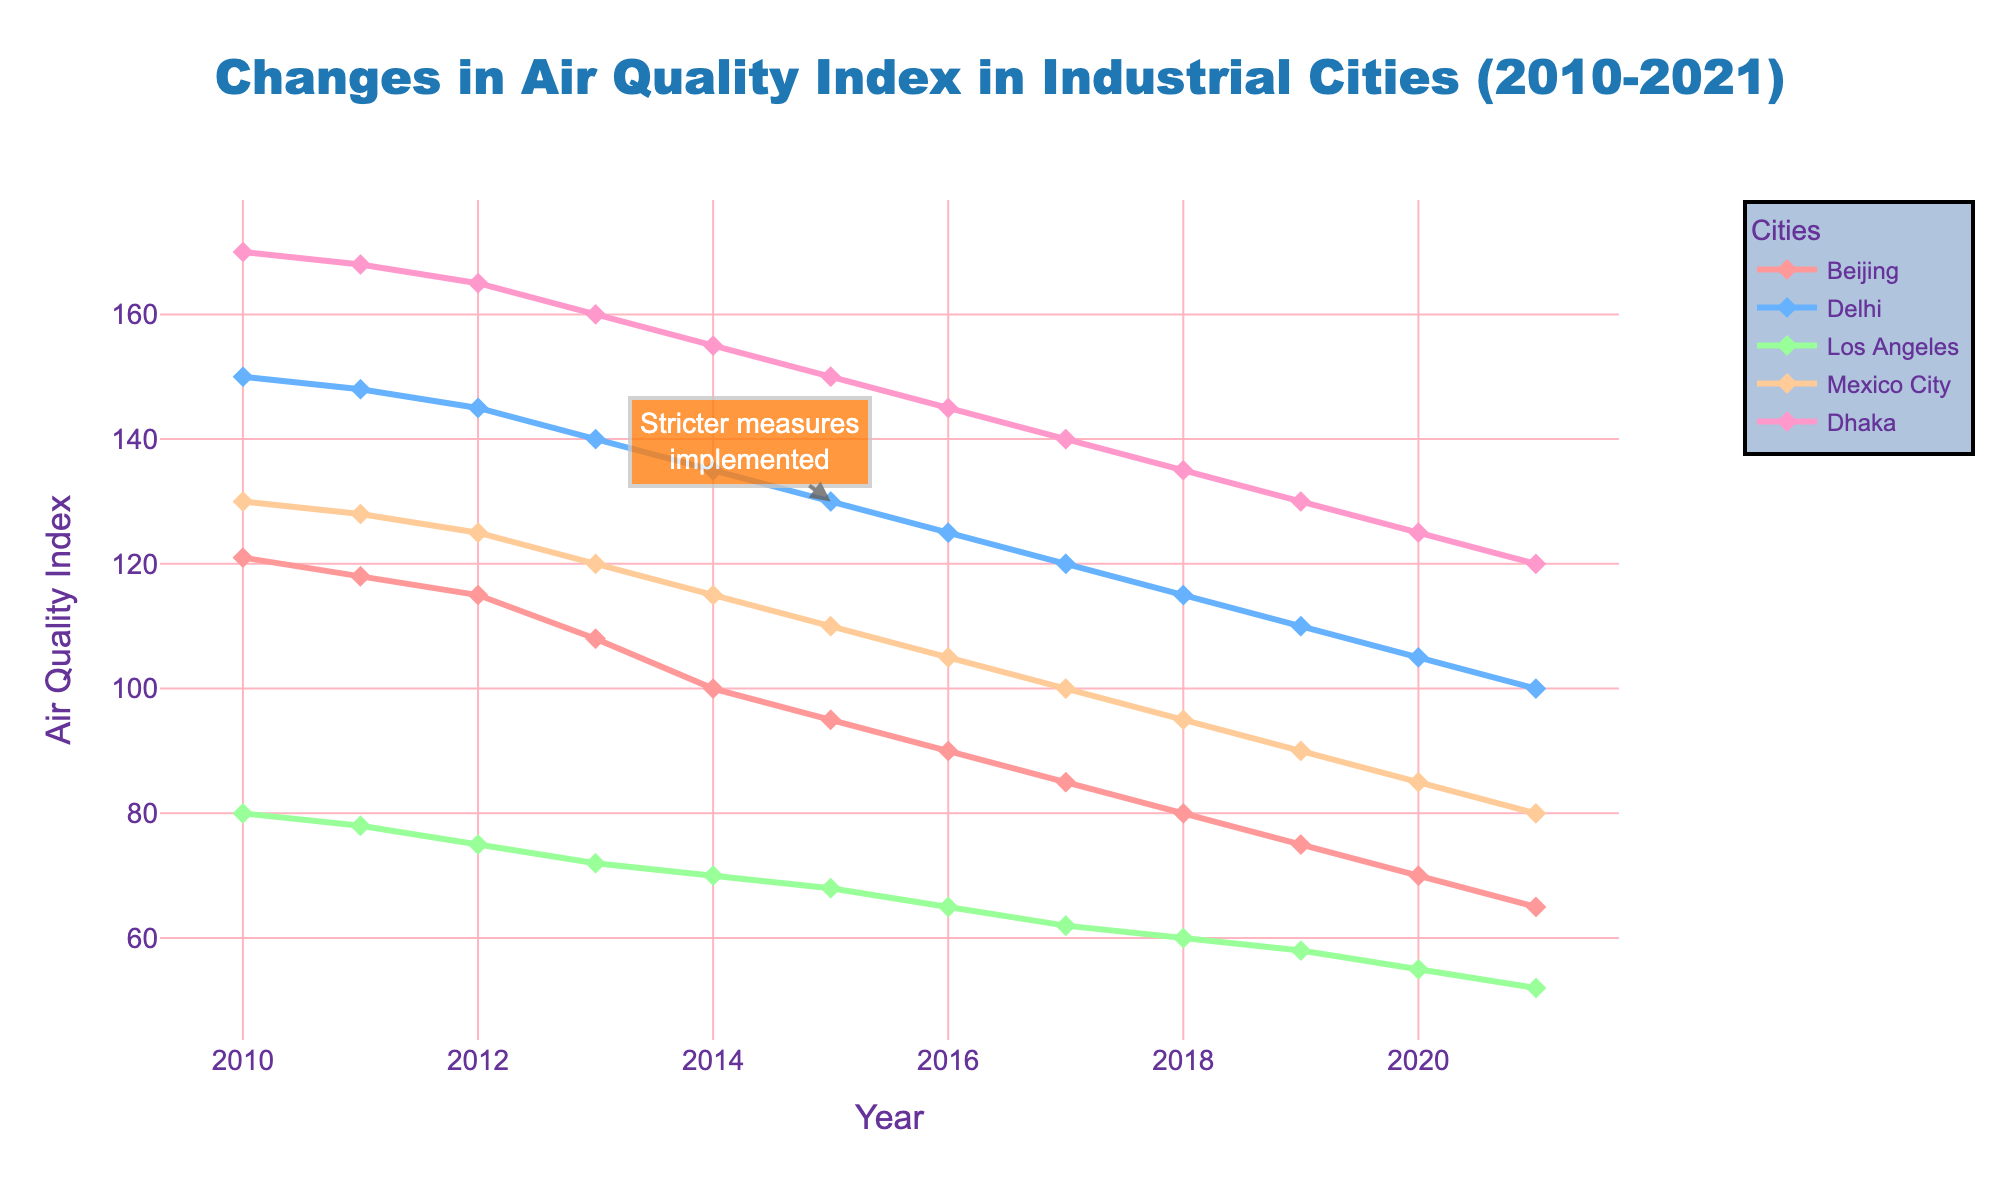Which city had the highest Air Quality Index (AQI) in 2010? By looking at the AQI values for each city in 2010, we see the highest number among all cities.
Answer: Dhaka Which city showed the greatest reduction in AQI from 2010 to 2021? By comparing the difference in AQI from 2010 to 2021 for each city, calculate the reduction: Beijing (121-65), Delhi (150-100), Los Angeles (80-52), Mexico City (130-80), Dhaka (170-120). Beijing: 56, Delhi: 50, Los Angeles: 28, Mexico City: 50, Dhaka: 50. Beijing showed the greatest reduction.
Answer: Beijing What was the average AQI of Los Angeles from 2010 to 2021? To find the average AQI, sum the yearly AQI values of Los Angeles from 2010 to 2021 and divide by the number of years (12). Sum = 80+78+75+72+70+68+65+62+60+58+55+52 = 795. Average = 795 / 12 = 66.25.
Answer: 66.25 How did the AQI in Mexico City change after 2015 compared to before 2015? To determine the change, calculate the average AQI for Mexico City from 2010 to 2015 (130, 128, 125, 120, 115, 110) and from 2016 to 2021 (105, 100, 95, 90, 85, 80). Before 2015 average = (130+128+125+120+115+110) / 6 = 121.33. After 2015 average = (105+100+95+90+85+80) / 6 = 92.50. The AQI decreased after 2015.
Answer: Decreased Which city had a consistent decline in AQI every year from 2010 to 2021? By inspecting the AQI values year by year for each city, Delhi consistently decreased every year without any increases.
Answer: Delhi Between 2014 and 2015, which city had the smallest decrease in AQI? Calculate the AQI decrease for each city between 2014 and 2015: Beijing (100-95=5), Delhi (135-130=5), Los Angeles (70-68=2), Mexico City (115-110=5), Dhaka (155-150=5). Los Angeles had the smallest decrease.
Answer: Los Angeles What is the total reduction in AQI for Dhaka from 2010 to 2021? Calculate the difference between the 2010 and 2021 AQI values for Dhaka: 170 - 120 = 50.
Answer: 50 How did the AQI of Beijing compare to Delhi in 2015? By directly looking at the 2015 values for Beijing (95) and Delhi (130) in the figure, Beijing had a lower AQI.
Answer: Lower What is the combined AQI of Los Angeles and Mexico City in 2018? Add the AQI values for both cities in 2018: Los Angeles (60) + Mexico City (95) = 155.
Answer: 155 Which city was the first to drop below an AQI of 70, and in what year? By examining the AQI values, Los Angeles dropped below an AQI of 70 first in 2017 with an AQI of 62.
Answer: Los Angeles in 2017 